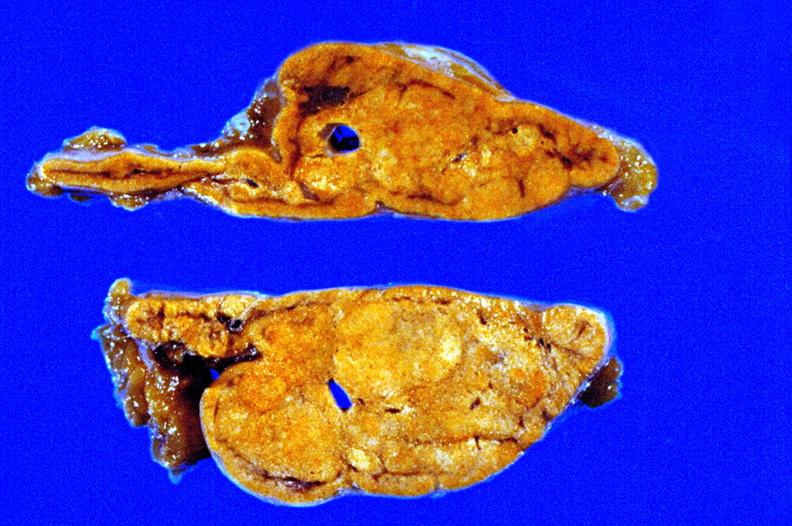what is present?
Answer the question using a single word or phrase. Adrenal 